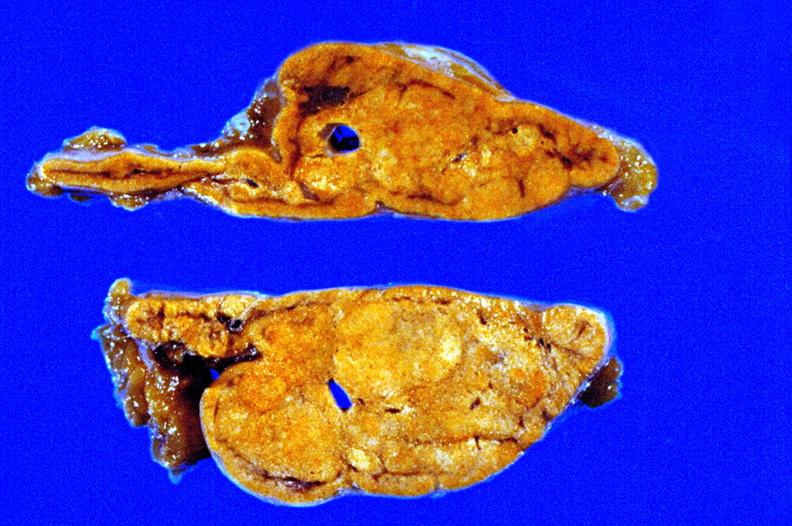what is present?
Answer the question using a single word or phrase. Adrenal 